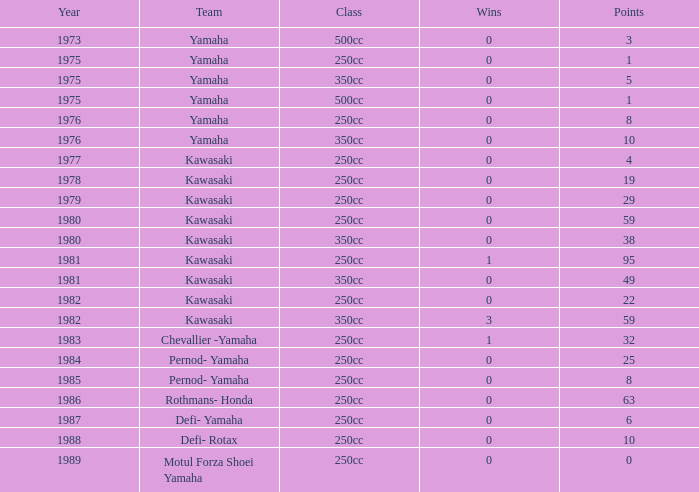Which highest wins number had Kawasaki as a team, 95 points, and a year prior to 1981? None. 